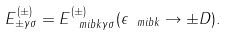<formula> <loc_0><loc_0><loc_500><loc_500>E ^ { ( \pm ) } _ { \pm \gamma \sigma } = E ^ { ( \pm ) } _ { { \ m i b k } \gamma \sigma } ( \epsilon _ { \ m i b k } \to \pm D ) .</formula> 